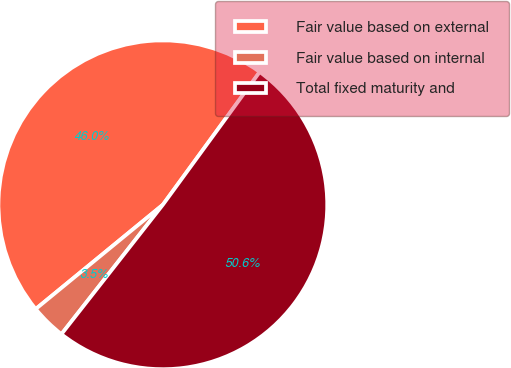Convert chart to OTSL. <chart><loc_0><loc_0><loc_500><loc_500><pie_chart><fcel>Fair value based on external<fcel>Fair value based on internal<fcel>Total fixed maturity and<nl><fcel>45.96%<fcel>3.49%<fcel>50.55%<nl></chart> 